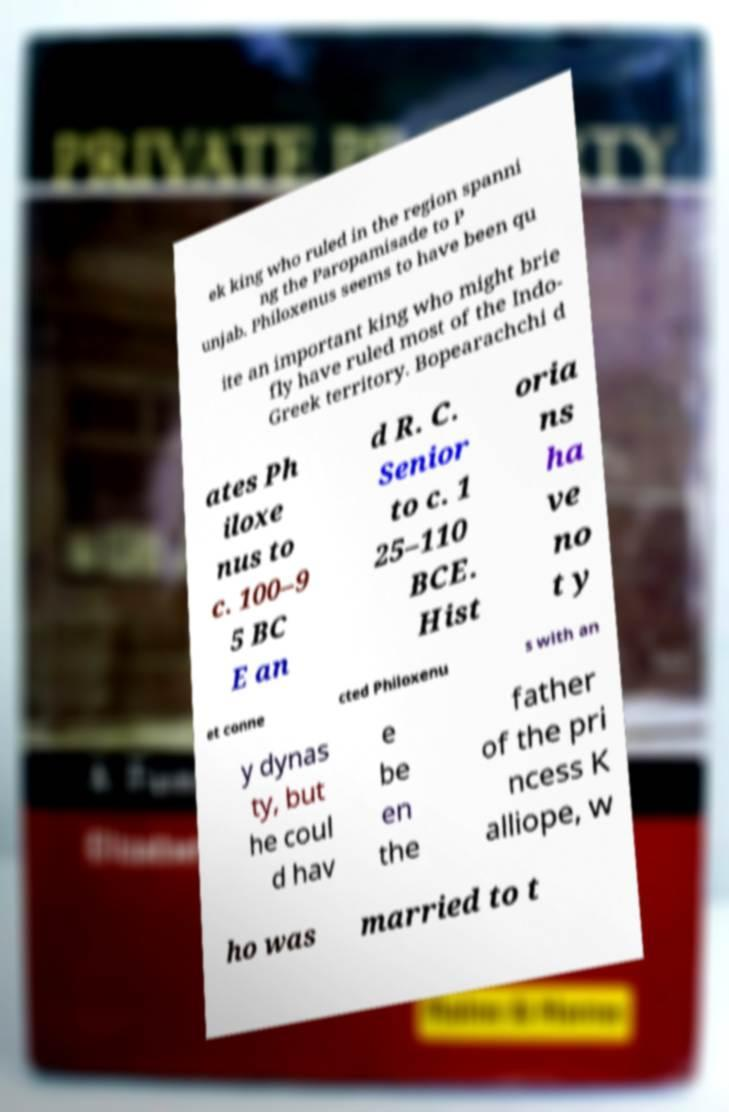Can you accurately transcribe the text from the provided image for me? ek king who ruled in the region spanni ng the Paropamisade to P unjab. Philoxenus seems to have been qu ite an important king who might brie fly have ruled most of the Indo- Greek territory. Bopearachchi d ates Ph iloxe nus to c. 100–9 5 BC E an d R. C. Senior to c. 1 25–110 BCE. Hist oria ns ha ve no t y et conne cted Philoxenu s with an y dynas ty, but he coul d hav e be en the father of the pri ncess K alliope, w ho was married to t 